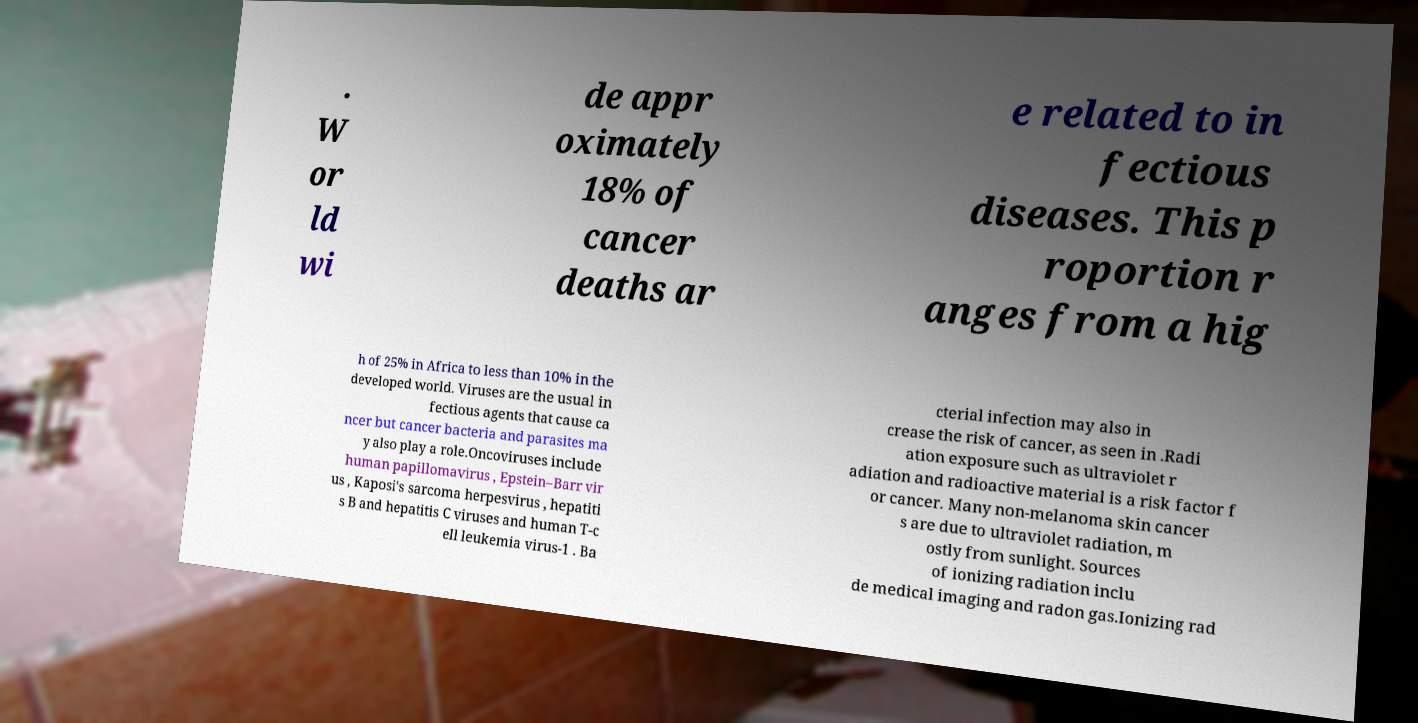There's text embedded in this image that I need extracted. Can you transcribe it verbatim? . W or ld wi de appr oximately 18% of cancer deaths ar e related to in fectious diseases. This p roportion r anges from a hig h of 25% in Africa to less than 10% in the developed world. Viruses are the usual in fectious agents that cause ca ncer but cancer bacteria and parasites ma y also play a role.Oncoviruses include human papillomavirus , Epstein–Barr vir us , Kaposi's sarcoma herpesvirus , hepatiti s B and hepatitis C viruses and human T-c ell leukemia virus-1 . Ba cterial infection may also in crease the risk of cancer, as seen in .Radi ation exposure such as ultraviolet r adiation and radioactive material is a risk factor f or cancer. Many non-melanoma skin cancer s are due to ultraviolet radiation, m ostly from sunlight. Sources of ionizing radiation inclu de medical imaging and radon gas.Ionizing rad 